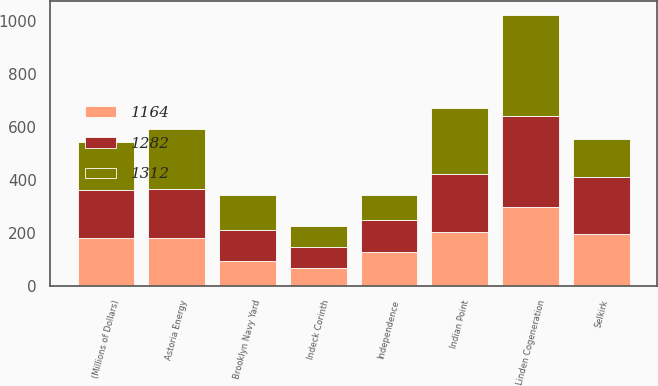Convert chart. <chart><loc_0><loc_0><loc_500><loc_500><stacked_bar_chart><ecel><fcel>(Millions of Dollars)<fcel>Brooklyn Navy Yard<fcel>Linden Cogeneration<fcel>Indeck Corinth<fcel>Indian Point<fcel>Astoria Energy<fcel>Selkirk<fcel>Independence<nl><fcel>1312<fcel>181<fcel>133<fcel>381<fcel>80<fcel>247<fcel>230<fcel>144<fcel>97<nl><fcel>1282<fcel>181<fcel>118<fcel>346<fcel>79<fcel>220<fcel>183<fcel>215<fcel>121<nl><fcel>1164<fcel>181<fcel>93<fcel>297<fcel>66<fcel>204<fcel>181<fcel>196<fcel>127<nl></chart> 